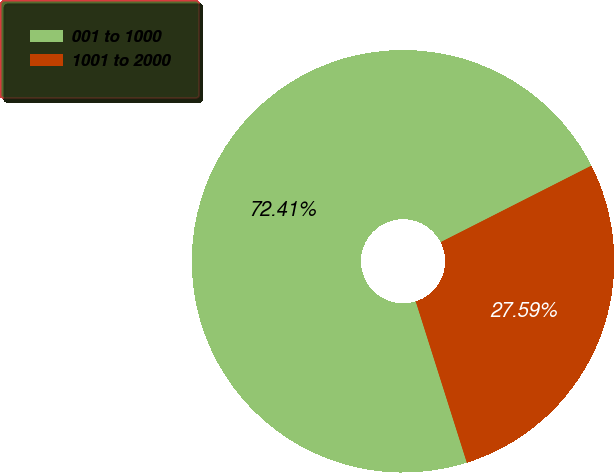<chart> <loc_0><loc_0><loc_500><loc_500><pie_chart><fcel>001 to 1000<fcel>1001 to 2000<nl><fcel>72.41%<fcel>27.59%<nl></chart> 